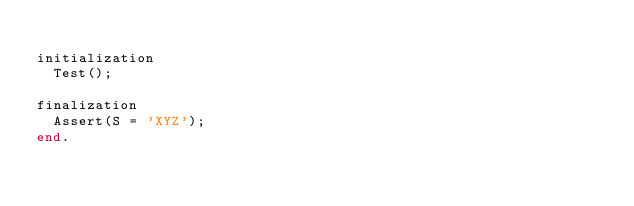Convert code to text. <code><loc_0><loc_0><loc_500><loc_500><_Pascal_>
initialization
  Test();

finalization
  Assert(S = 'XYZ');
end.</code> 